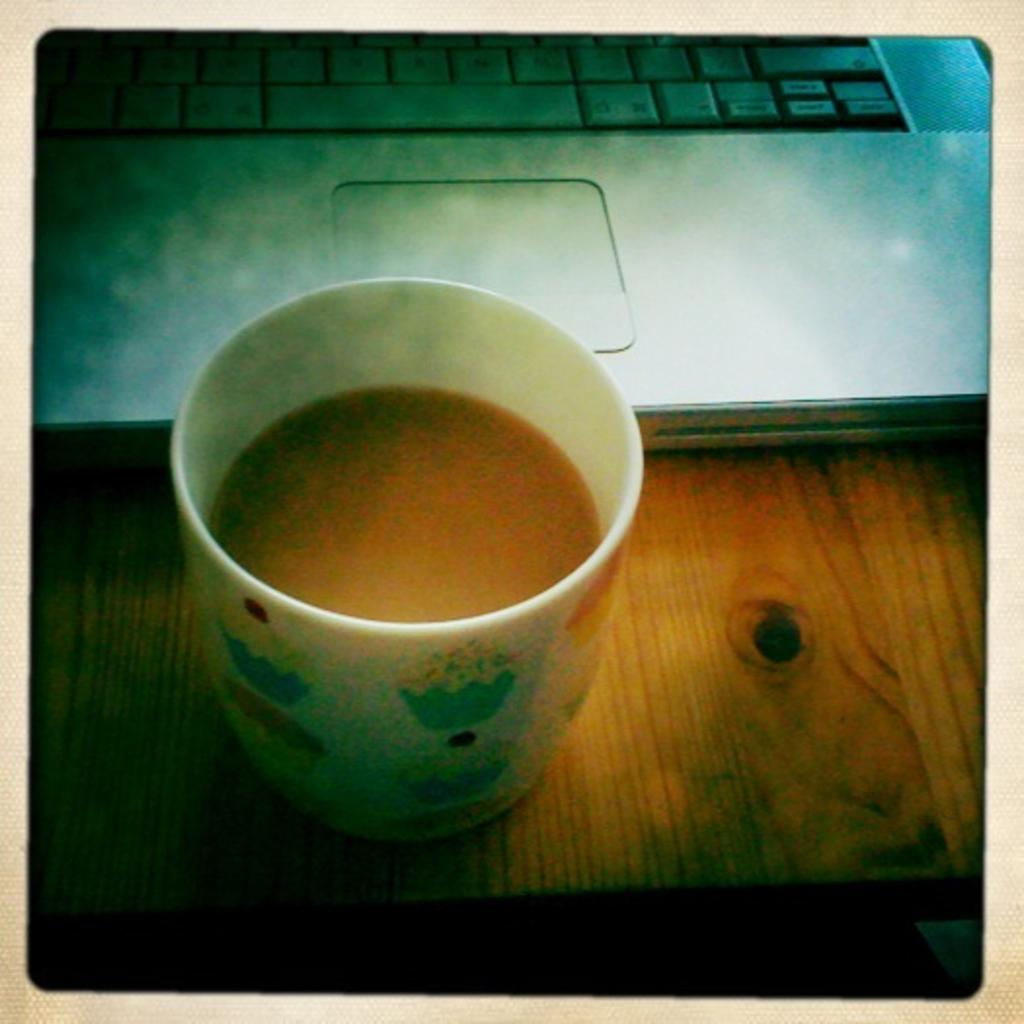What color is the cup that is visible in the image? There is a white color cup in the image. What is inside the cup? The cup contains tea. What electronic device is present in the image? There is a laptop in the image. What type of surface is the laptop placed on? The laptop is on a wooden floor. How many geese are sleeping on the boat in the image? There is no boat or geese present in the image. 